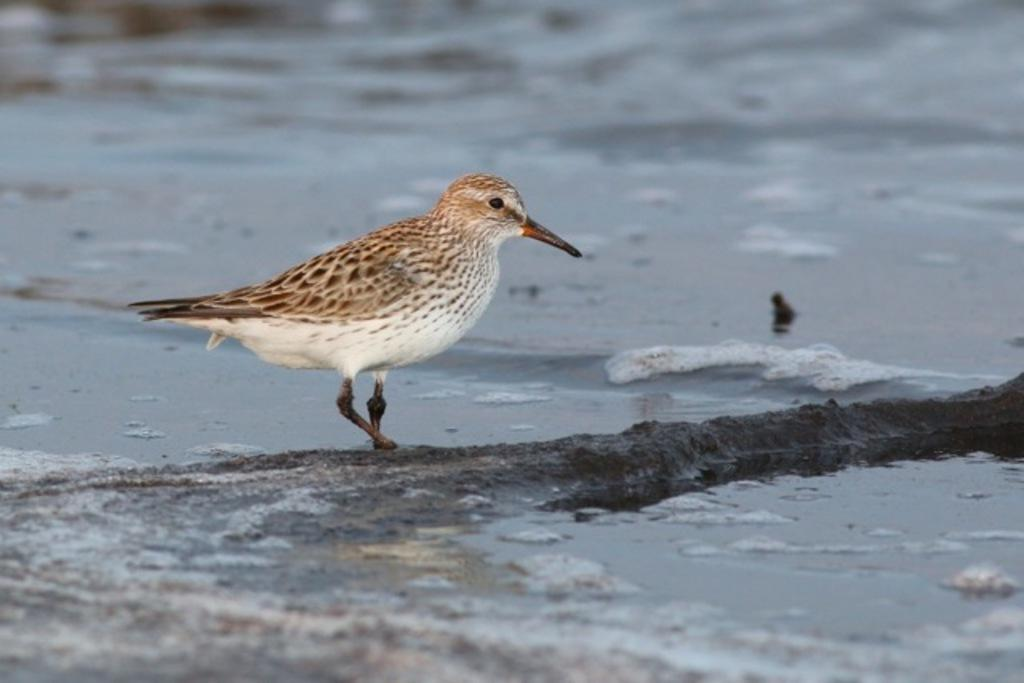What type of animal can be seen in the image? There is a bird in the image. Where is the bird located? The bird is on the sand. What can be seen in the background of the image? There is a river in the background of the image. What type of coat is the bird wearing in the image? Birds do not wear coats, so there is no coat present in the image. 